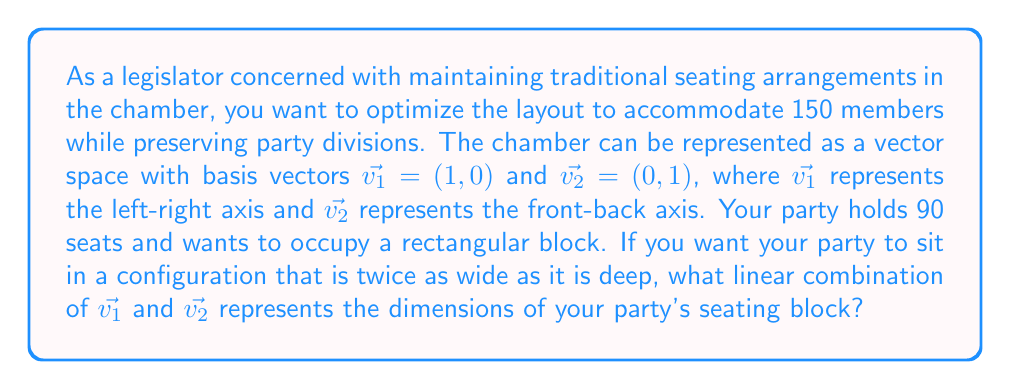What is the answer to this math problem? Let's approach this step-by-step:

1) First, we need to determine the dimensions of the rectangular block that will seat 90 members.

2) We're told that the width should be twice the depth. Let's call the depth $y$ and the width $2y$.

3) The area of this rectangle should equal the number of seats:

   $2y \cdot y = 90$
   $2y^2 = 90$
   $y^2 = 45$
   $y = \sqrt{45} = 3\sqrt{5}$

4) So, the depth is $3\sqrt{5}$ and the width is $2(3\sqrt{5}) = 6\sqrt{5}$.

5) Now, we need to represent this as a linear combination of $\vec{v_1}$ and $\vec{v_2}$.

6) The width ($6\sqrt{5}$) is along the $\vec{v_1}$ axis, and the depth ($3\sqrt{5}$) is along the $\vec{v_2}$ axis.

7) Therefore, the linear combination we're looking for is:

   $6\sqrt{5}\vec{v_1} + 3\sqrt{5}\vec{v_2}$

8) We can factor out $3\sqrt{5}$ to simplify:

   $3\sqrt{5}(2\vec{v_1} + \vec{v_2})$

This linear combination represents the dimensions of the seating block that satisfies the given conditions.
Answer: $3\sqrt{5}(2\vec{v_1} + \vec{v_2})$ 